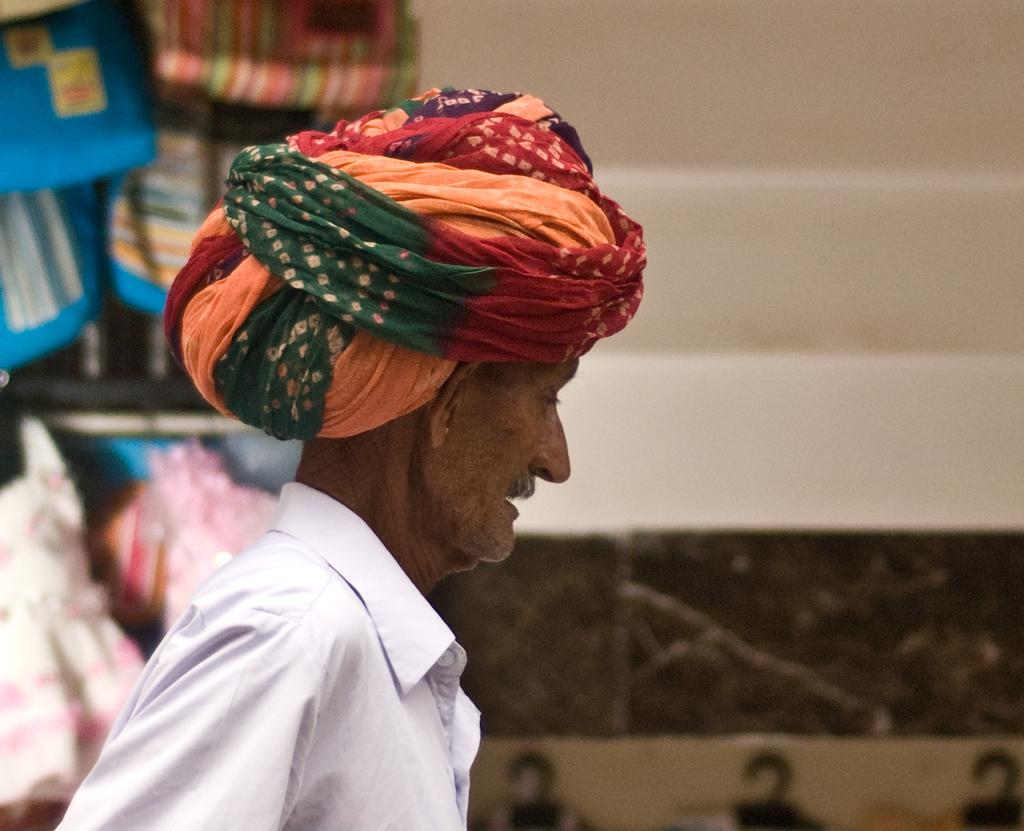What is the main subject of the image? There is a person in the image. Can you describe the background of the image? There are objects in the background of the image. What type of sack is being blown by the tank in the image? There is no tank, sack, or blowing action present in the image. 